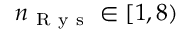Convert formula to latex. <formula><loc_0><loc_0><loc_500><loc_500>n _ { R y s } \in [ 1 , 8 )</formula> 